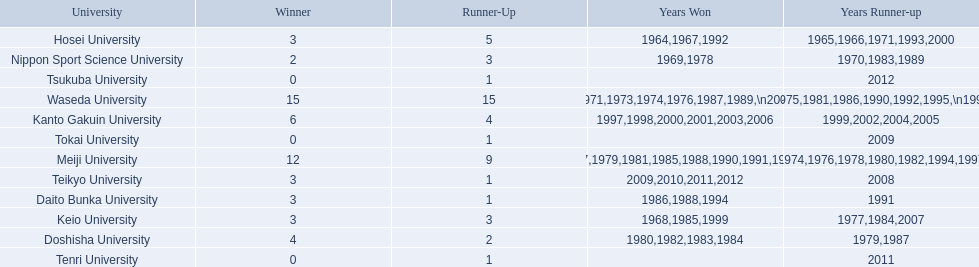What are all of the universities? Waseda University, Meiji University, Kanto Gakuin University, Doshisha University, Hosei University, Keio University, Daito Bunka University, Nippon Sport Science University, Teikyo University, Tokai University, Tenri University, Tsukuba University. And their scores? 15, 12, 6, 4, 3, 3, 3, 2, 3, 0, 0, 0. Which university scored won the most? Waseda University. 